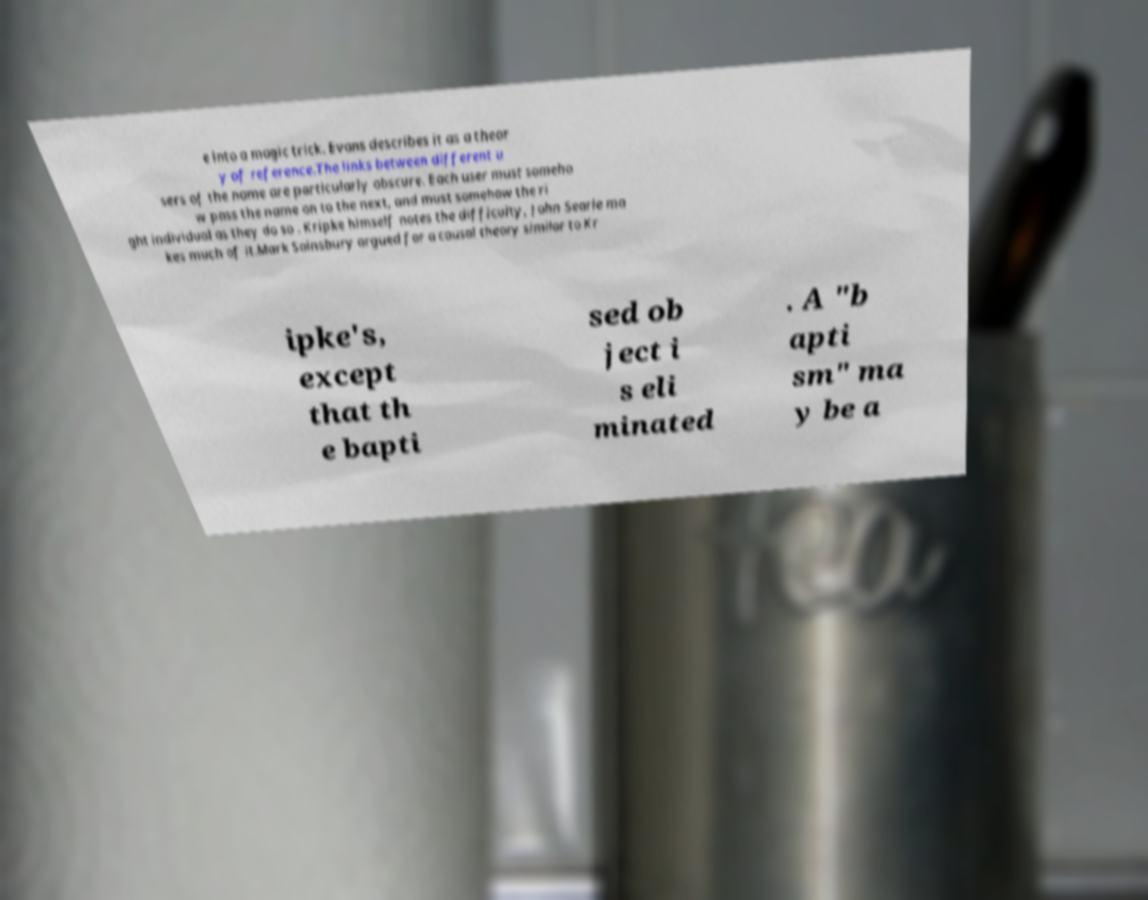Please read and relay the text visible in this image. What does it say? e into a magic trick. Evans describes it as a theor y of reference.The links between different u sers of the name are particularly obscure. Each user must someho w pass the name on to the next, and must somehow the ri ght individual as they do so . Kripke himself notes the difficulty, John Searle ma kes much of it.Mark Sainsbury argued for a causal theory similar to Kr ipke's, except that th e bapti sed ob ject i s eli minated . A "b apti sm" ma y be a 